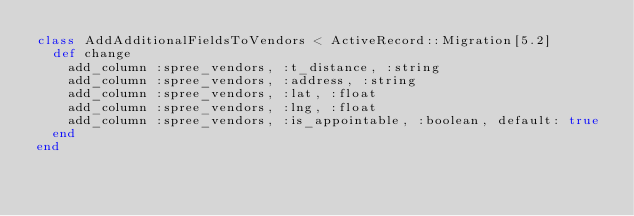<code> <loc_0><loc_0><loc_500><loc_500><_Ruby_>class AddAdditionalFieldsToVendors < ActiveRecord::Migration[5.2]
  def change
  	add_column :spree_vendors, :t_distance, :string
  	add_column :spree_vendors, :address, :string
  	add_column :spree_vendors, :lat, :float
  	add_column :spree_vendors, :lng, :float
  	add_column :spree_vendors, :is_appointable, :boolean, default: true
  end
end

</code> 